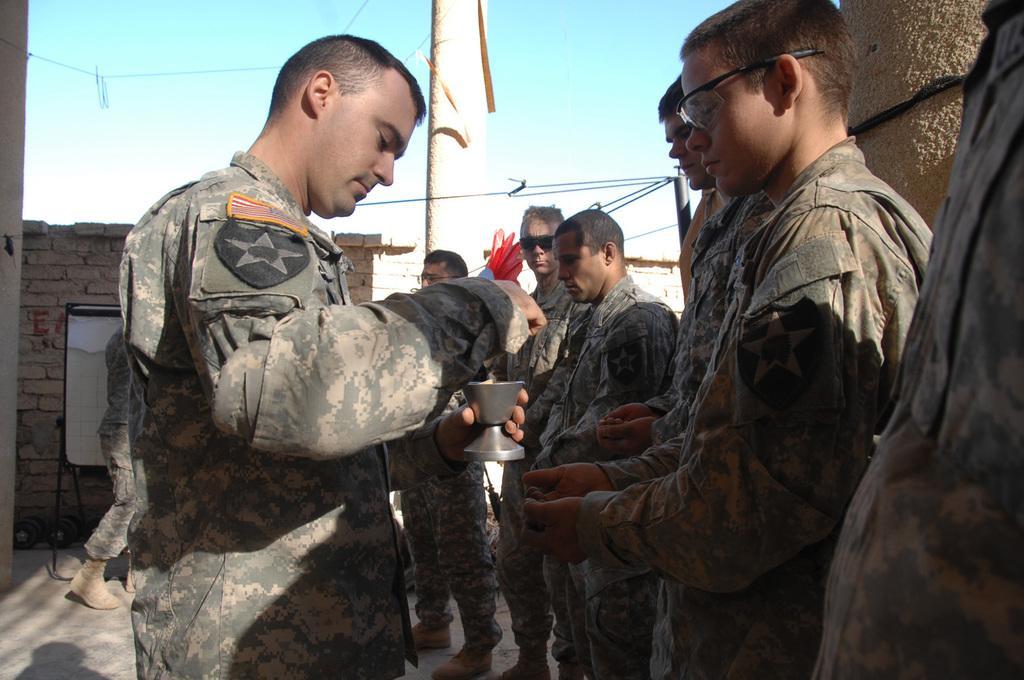Please provide a concise description of this image. In this picture we can see some military soldiers, standing in the Que. In the front we can see a soldier standing and holding the silver tea cup in his hand. Behind there are some brick walls. On the top we can see the sky and clouds. 